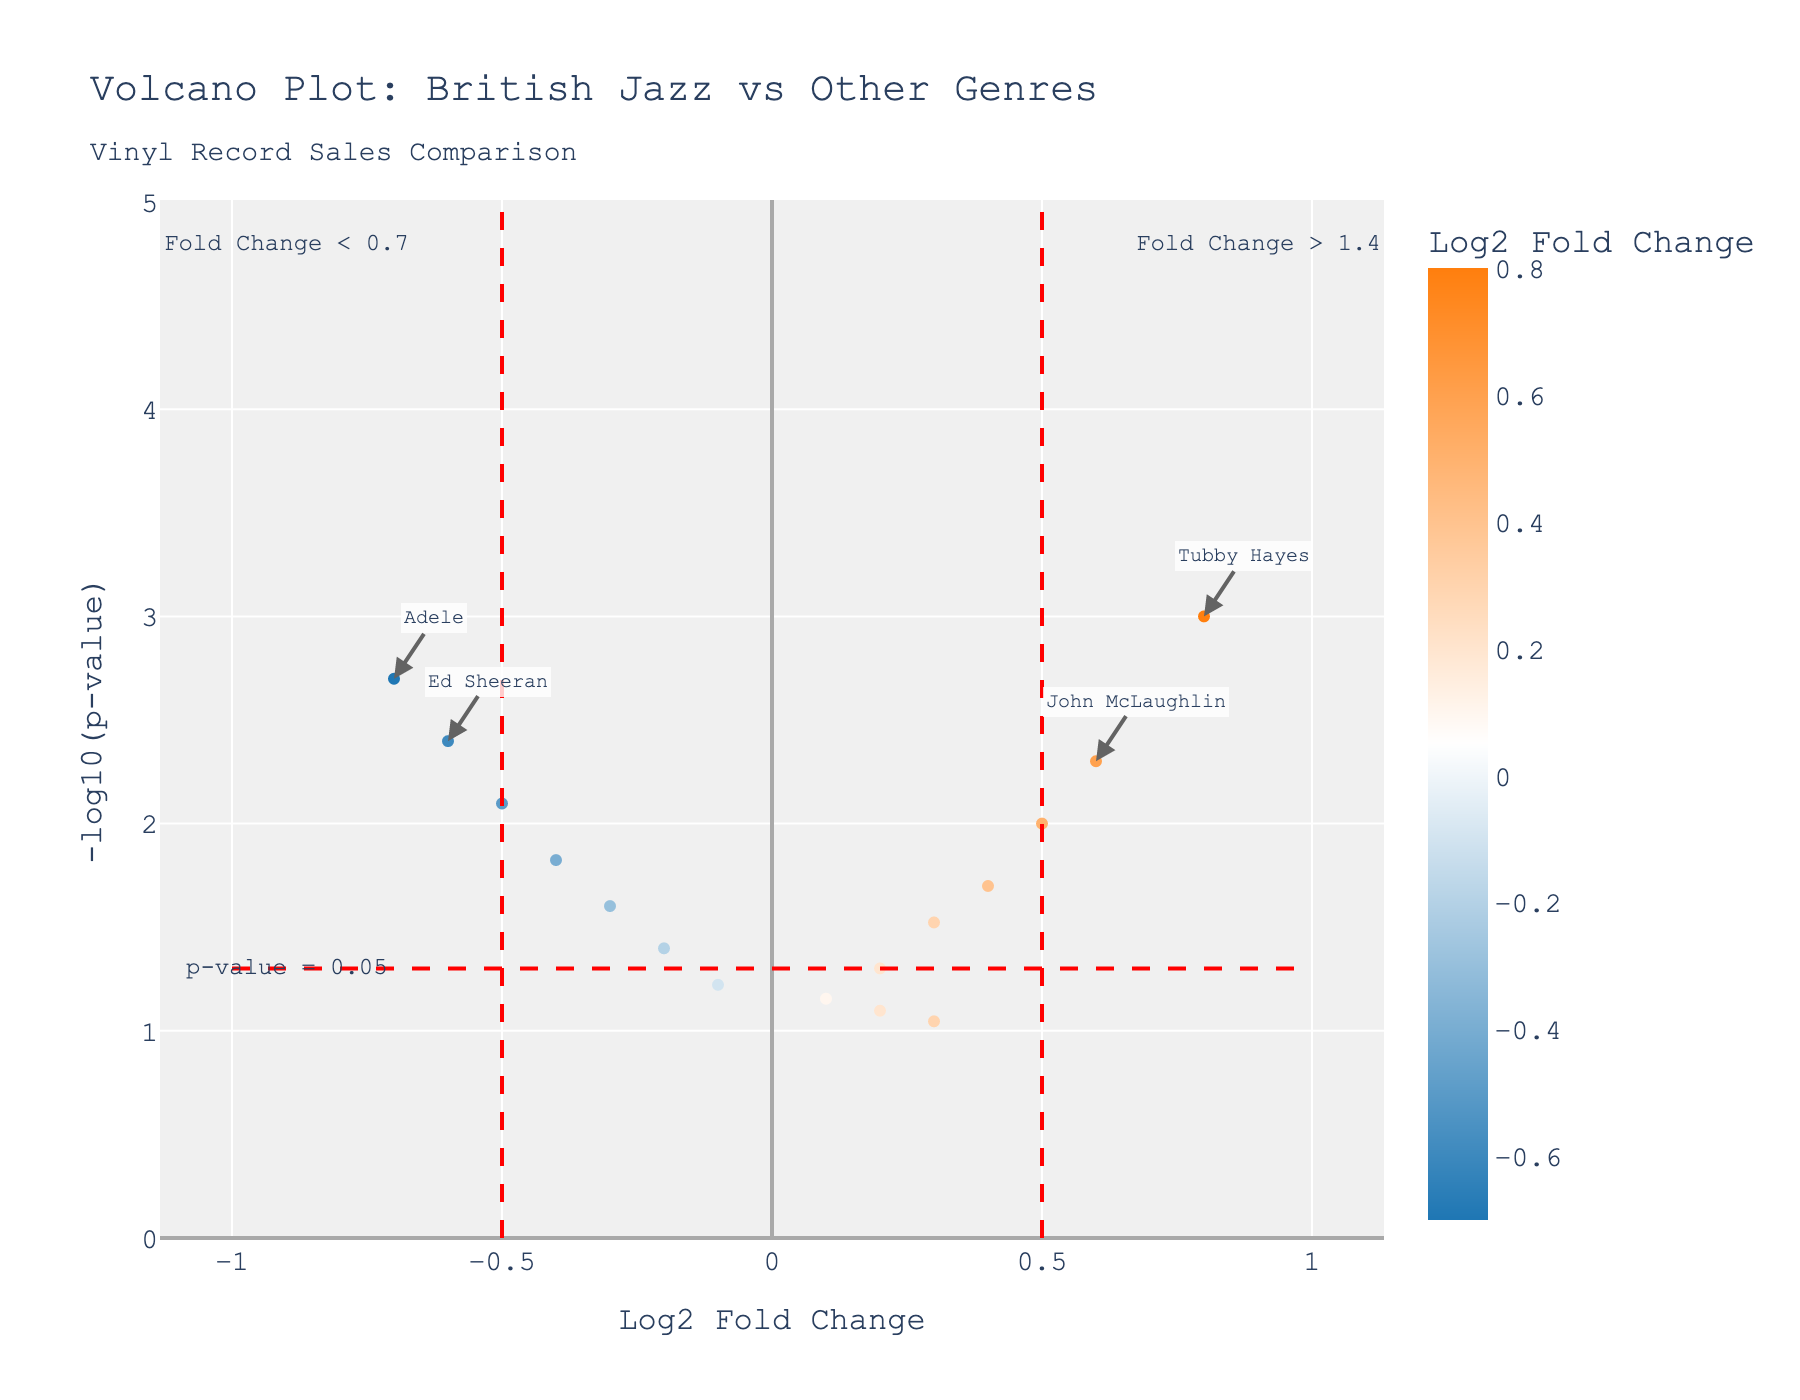How many British Jazz artists are present in the plot? The figure presents a scatter plot with a color-coded legend for different genres. By observing which points are labeled as British Jazz artists, we can count them.
Answer: 6 What is the log2 fold change for Tubby Hayes? Tubby Hayes is labeled on the plot, and if we locate his point, we can see the x-axis value corresponding to his position, which represents the log2 fold change.
Answer: 0.8 Which artist has the smallest p-value and what genre do they belong to? The smallest p-value corresponds to the highest '-log10(p-value)' on the y-axis. Locate this maximum point on the plot and check the label for the artist and their genre.
Answer: Tubby Hayes, British Jazz Which data point represents an artist from the Pop genre with a negative log2 fold change? Points in the plot are colored and hover data reveals their genre. Identify the points within the negative log2 fold change region (left side of the x-axis) and locate the ones that show Pop as their genre.
Answer: Adele or Ed Sheeran How does Ronnie Scott compared to The Beatles in terms of p-value? Find the position of both Ronnie Scott and The Beatles. Compare their y-axis values, as a higher y-axis value (-log10(p-value)) indicates a smaller p-value.
Answer: Ronnie Scott has a larger p-value than The Beatles Which artist has the highest log2 fold change among those with significant results (p-value < 0.05)? First, identify points with a y-axis value greater than -log10(0.05). Then, among these points, find the one with the maximum x-axis value.
Answer: Tubby Hayes Is Jamie Cullum's p-value above or below the significance threshold of 0.05? Locate Jamie Cullum's point on the plot. If it is above the horizontal threshold line (p-value = 0.05), then the p-value is below the significance threshold.
Answer: Below What does the red dashed vertical line at x = 0.5 indicate in the plot? The red dashed lines highlight specific log2 fold change thresholds. By observing the annotation near the line, it explains the significance of the threshold.
Answer: Fold Change > 1.4 Identify a British Jazz artist with a p-value just on the borderline of significance (around 0.05). Look for British Jazz artists points located near the red dashed horizontal line indicating p-value = 0.05. Check the label of the nearest point.
Answer: Jamie Cullum 